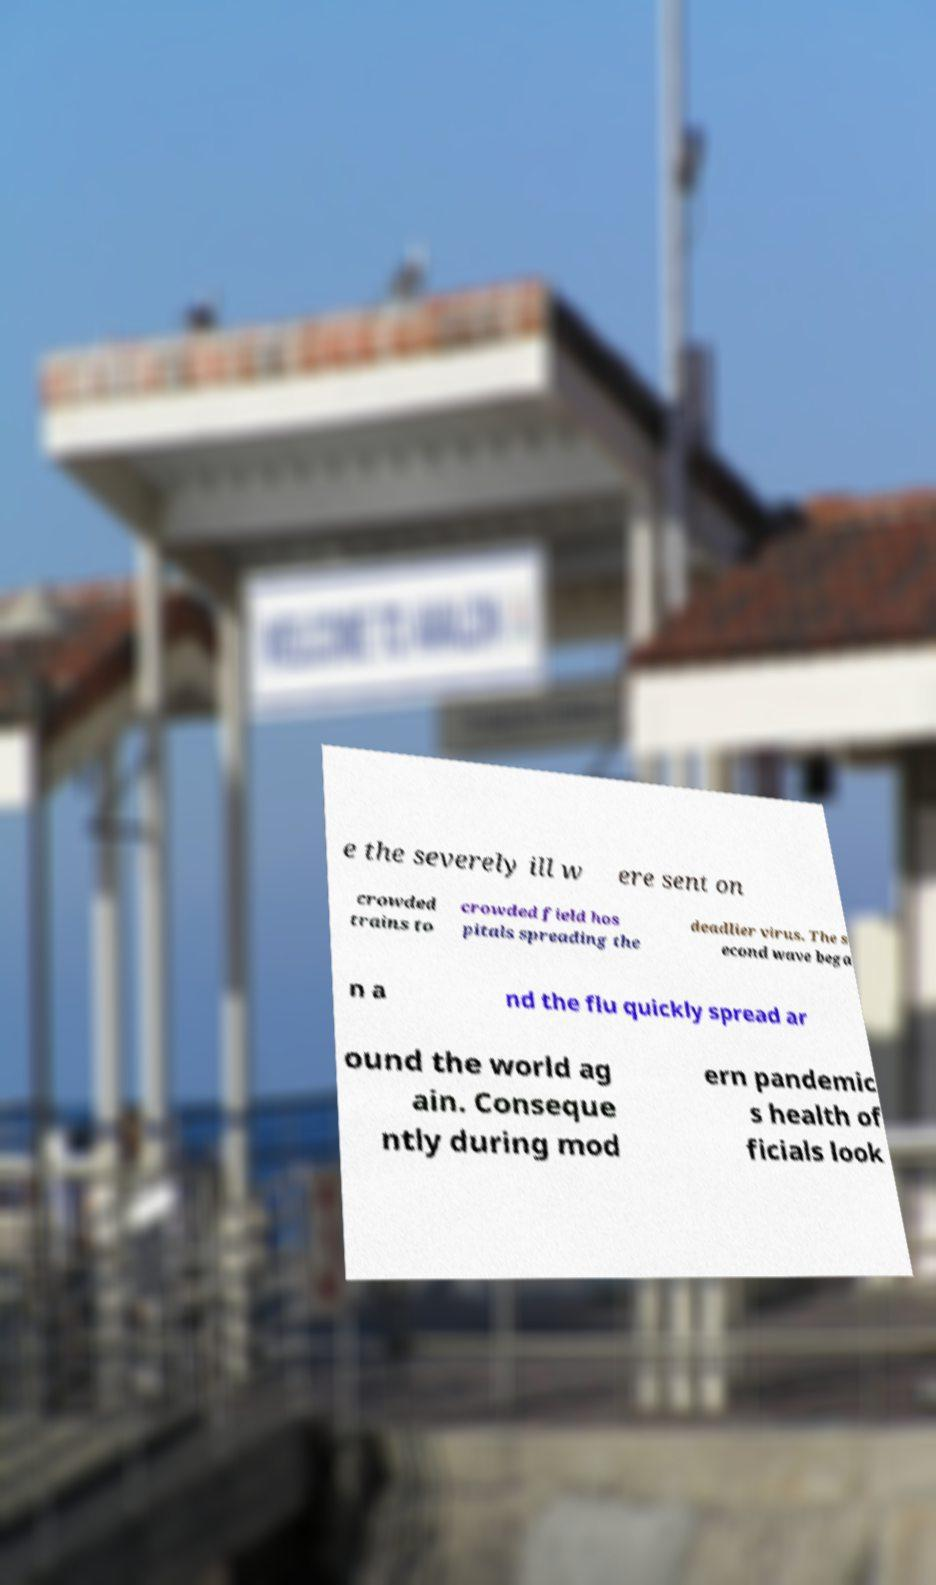For documentation purposes, I need the text within this image transcribed. Could you provide that? e the severely ill w ere sent on crowded trains to crowded field hos pitals spreading the deadlier virus. The s econd wave bega n a nd the flu quickly spread ar ound the world ag ain. Conseque ntly during mod ern pandemic s health of ficials look 